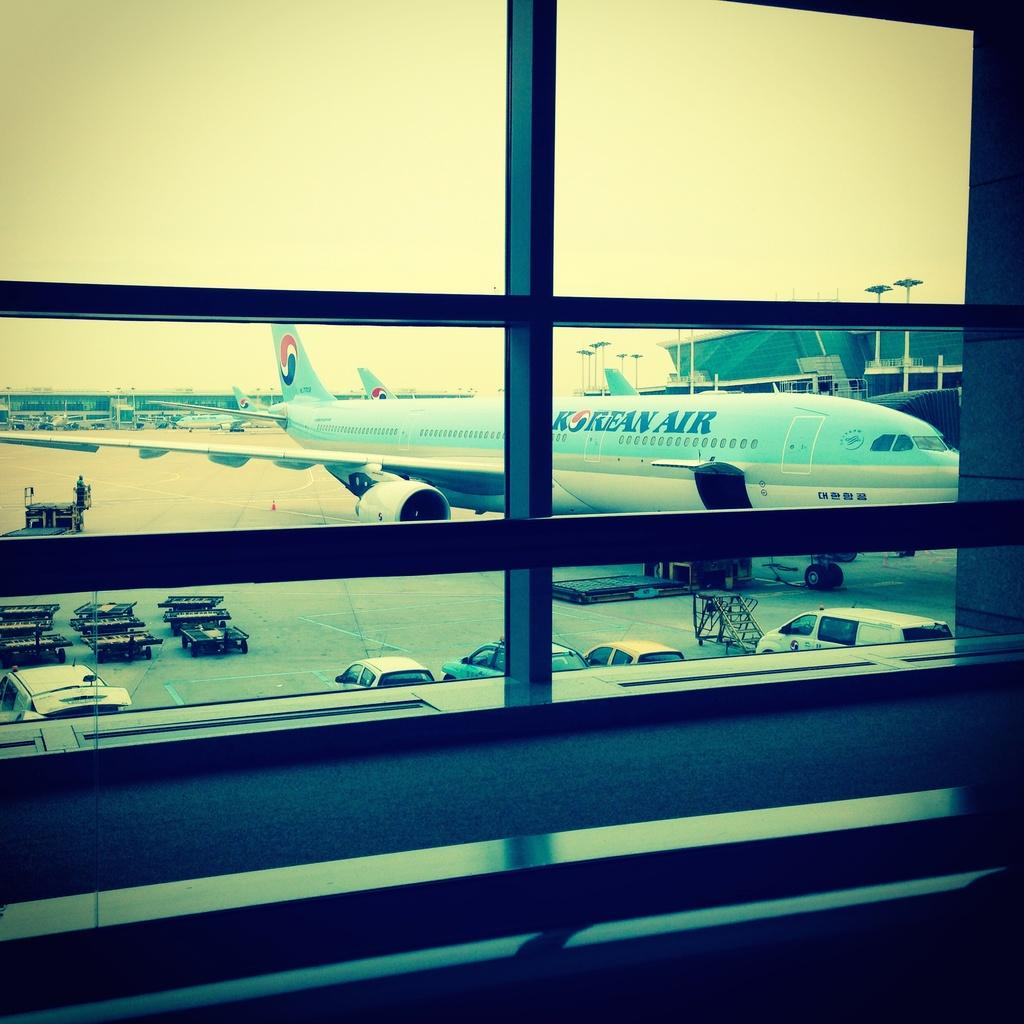<image>
Provide a brief description of the given image. a korean air airplane sitting on the runway 